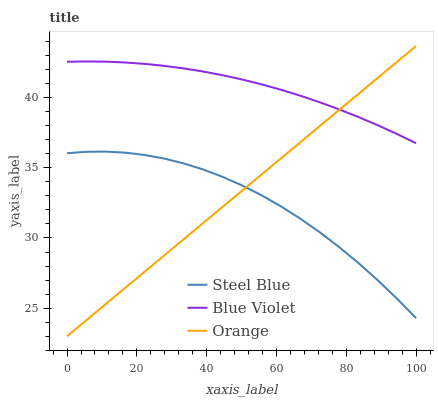Does Steel Blue have the minimum area under the curve?
Answer yes or no. Yes. Does Blue Violet have the maximum area under the curve?
Answer yes or no. Yes. Does Blue Violet have the minimum area under the curve?
Answer yes or no. No. Does Steel Blue have the maximum area under the curve?
Answer yes or no. No. Is Orange the smoothest?
Answer yes or no. Yes. Is Steel Blue the roughest?
Answer yes or no. Yes. Is Blue Violet the smoothest?
Answer yes or no. No. Is Blue Violet the roughest?
Answer yes or no. No. Does Steel Blue have the lowest value?
Answer yes or no. No. Does Orange have the highest value?
Answer yes or no. Yes. Does Blue Violet have the highest value?
Answer yes or no. No. Is Steel Blue less than Blue Violet?
Answer yes or no. Yes. Is Blue Violet greater than Steel Blue?
Answer yes or no. Yes. Does Orange intersect Blue Violet?
Answer yes or no. Yes. Is Orange less than Blue Violet?
Answer yes or no. No. Is Orange greater than Blue Violet?
Answer yes or no. No. Does Steel Blue intersect Blue Violet?
Answer yes or no. No. 